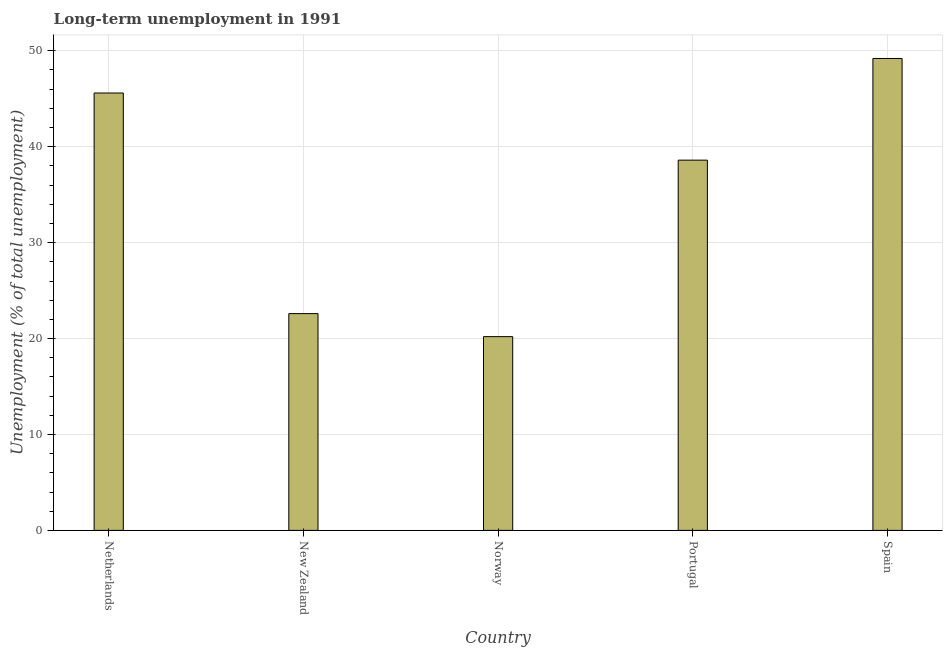Does the graph contain any zero values?
Provide a short and direct response. No. Does the graph contain grids?
Give a very brief answer. Yes. What is the title of the graph?
Your answer should be very brief. Long-term unemployment in 1991. What is the label or title of the Y-axis?
Ensure brevity in your answer.  Unemployment (% of total unemployment). What is the long-term unemployment in New Zealand?
Offer a very short reply. 22.6. Across all countries, what is the maximum long-term unemployment?
Provide a short and direct response. 49.2. Across all countries, what is the minimum long-term unemployment?
Offer a terse response. 20.2. In which country was the long-term unemployment maximum?
Your response must be concise. Spain. What is the sum of the long-term unemployment?
Ensure brevity in your answer.  176.2. What is the average long-term unemployment per country?
Give a very brief answer. 35.24. What is the median long-term unemployment?
Your answer should be very brief. 38.6. In how many countries, is the long-term unemployment greater than 42 %?
Keep it short and to the point. 2. What is the ratio of the long-term unemployment in Netherlands to that in Spain?
Ensure brevity in your answer.  0.93. Is the long-term unemployment in Netherlands less than that in Spain?
Your answer should be very brief. Yes. What is the difference between the highest and the second highest long-term unemployment?
Offer a terse response. 3.6. What is the difference between the highest and the lowest long-term unemployment?
Offer a very short reply. 29. How many countries are there in the graph?
Give a very brief answer. 5. What is the Unemployment (% of total unemployment) of Netherlands?
Keep it short and to the point. 45.6. What is the Unemployment (% of total unemployment) of New Zealand?
Provide a short and direct response. 22.6. What is the Unemployment (% of total unemployment) in Norway?
Offer a terse response. 20.2. What is the Unemployment (% of total unemployment) in Portugal?
Offer a terse response. 38.6. What is the Unemployment (% of total unemployment) of Spain?
Make the answer very short. 49.2. What is the difference between the Unemployment (% of total unemployment) in Netherlands and Norway?
Provide a short and direct response. 25.4. What is the difference between the Unemployment (% of total unemployment) in Netherlands and Portugal?
Your response must be concise. 7. What is the difference between the Unemployment (% of total unemployment) in New Zealand and Portugal?
Provide a short and direct response. -16. What is the difference between the Unemployment (% of total unemployment) in New Zealand and Spain?
Ensure brevity in your answer.  -26.6. What is the difference between the Unemployment (% of total unemployment) in Norway and Portugal?
Ensure brevity in your answer.  -18.4. What is the difference between the Unemployment (% of total unemployment) in Portugal and Spain?
Ensure brevity in your answer.  -10.6. What is the ratio of the Unemployment (% of total unemployment) in Netherlands to that in New Zealand?
Your response must be concise. 2.02. What is the ratio of the Unemployment (% of total unemployment) in Netherlands to that in Norway?
Your answer should be very brief. 2.26. What is the ratio of the Unemployment (% of total unemployment) in Netherlands to that in Portugal?
Provide a short and direct response. 1.18. What is the ratio of the Unemployment (% of total unemployment) in Netherlands to that in Spain?
Give a very brief answer. 0.93. What is the ratio of the Unemployment (% of total unemployment) in New Zealand to that in Norway?
Your response must be concise. 1.12. What is the ratio of the Unemployment (% of total unemployment) in New Zealand to that in Portugal?
Ensure brevity in your answer.  0.58. What is the ratio of the Unemployment (% of total unemployment) in New Zealand to that in Spain?
Your response must be concise. 0.46. What is the ratio of the Unemployment (% of total unemployment) in Norway to that in Portugal?
Make the answer very short. 0.52. What is the ratio of the Unemployment (% of total unemployment) in Norway to that in Spain?
Your response must be concise. 0.41. What is the ratio of the Unemployment (% of total unemployment) in Portugal to that in Spain?
Give a very brief answer. 0.79. 